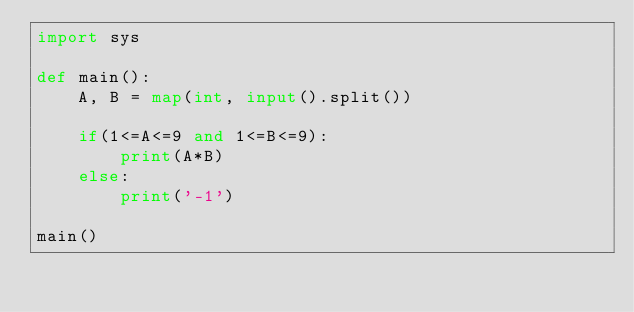Convert code to text. <code><loc_0><loc_0><loc_500><loc_500><_Python_>import sys
 
def main():
    A, B = map(int, input().split())
 
    if(1<=A<=9 and 1<=B<=9):
        print(A*B)
    else:
        print('-1')
 
main()
</code> 